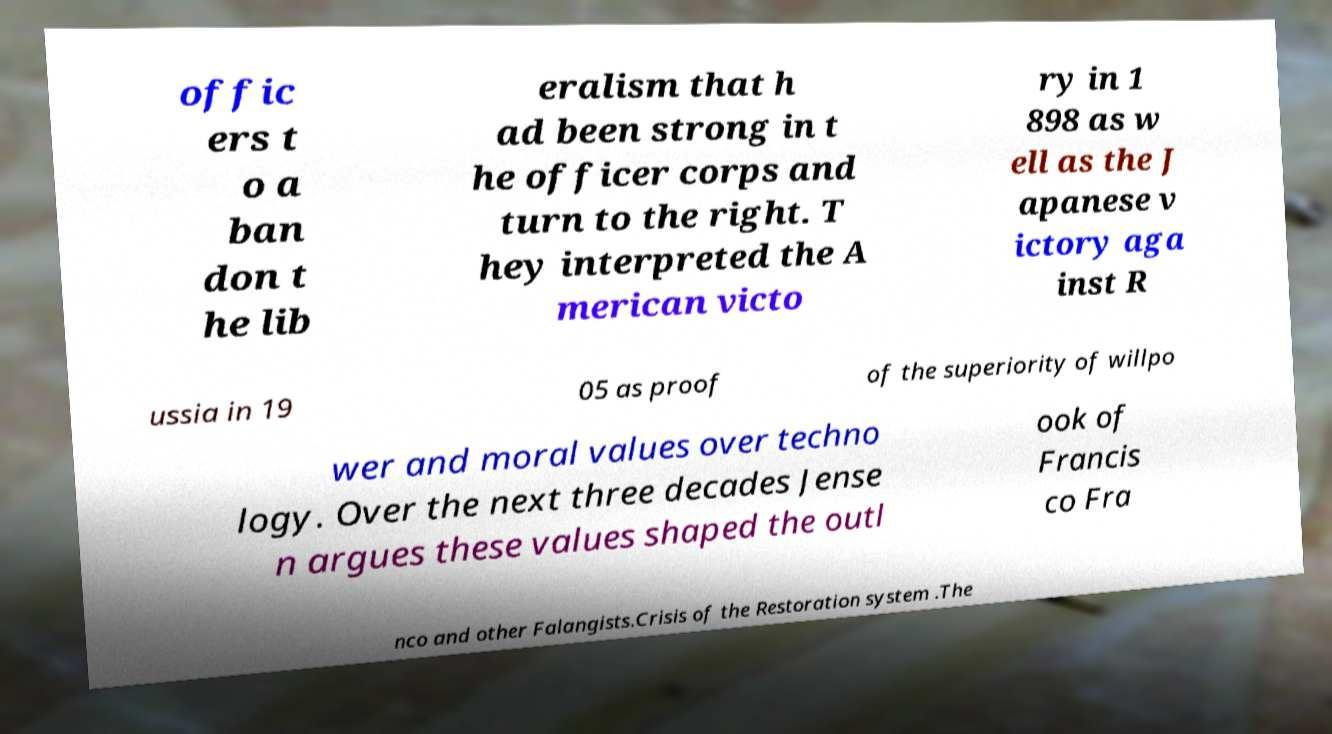Could you assist in decoding the text presented in this image and type it out clearly? offic ers t o a ban don t he lib eralism that h ad been strong in t he officer corps and turn to the right. T hey interpreted the A merican victo ry in 1 898 as w ell as the J apanese v ictory aga inst R ussia in 19 05 as proof of the superiority of willpo wer and moral values over techno logy. Over the next three decades Jense n argues these values shaped the outl ook of Francis co Fra nco and other Falangists.Crisis of the Restoration system .The 